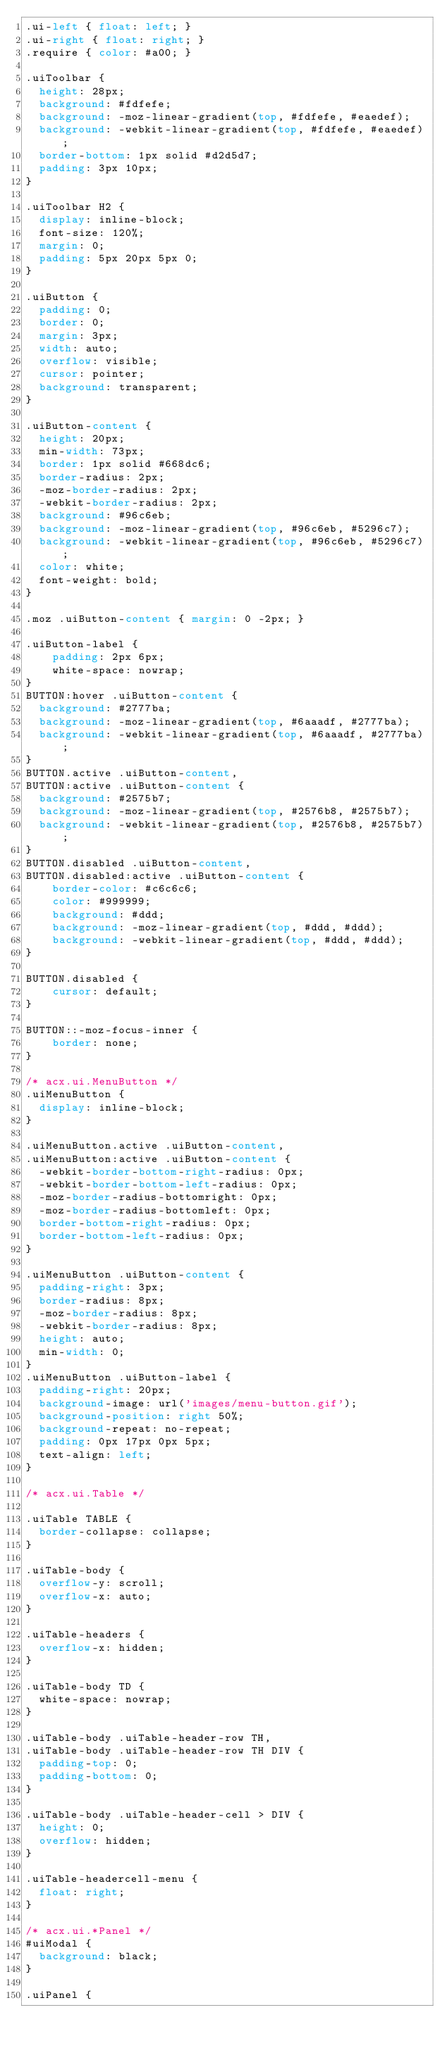Convert code to text. <code><loc_0><loc_0><loc_500><loc_500><_CSS_>.ui-left { float: left; }
.ui-right { float: right; }
.require { color: #a00; }

.uiToolbar {
	height: 28px;
	background: #fdfefe;
	background: -moz-linear-gradient(top, #fdfefe, #eaedef);
	background: -webkit-linear-gradient(top, #fdfefe, #eaedef);
	border-bottom: 1px solid #d2d5d7;
	padding: 3px 10px;
}

.uiToolbar H2 {
	display: inline-block;
	font-size: 120%;
	margin: 0;
	padding: 5px 20px 5px 0;
}

.uiButton {
	padding: 0;
	border: 0;
	margin: 3px;
	width: auto;
	overflow: visible;
	cursor: pointer;
	background: transparent;
}

.uiButton-content {
	height: 20px;
	min-width: 73px;
	border: 1px solid #668dc6;
	border-radius: 2px;
	-moz-border-radius: 2px;
	-webkit-border-radius: 2px;
	background: #96c6eb;
	background: -moz-linear-gradient(top, #96c6eb, #5296c7);
	background: -webkit-linear-gradient(top, #96c6eb, #5296c7);
	color: white;
	font-weight: bold;
}

.moz .uiButton-content { margin: 0 -2px; }

.uiButton-label {
    padding: 2px 6px;
    white-space: nowrap;
}
BUTTON:hover .uiButton-content {
	background: #2777ba;
	background: -moz-linear-gradient(top, #6aaadf, #2777ba);
	background: -webkit-linear-gradient(top, #6aaadf, #2777ba);
}
BUTTON.active .uiButton-content,
BUTTON:active .uiButton-content {
	background: #2575b7;
	background: -moz-linear-gradient(top, #2576b8, #2575b7);
	background: -webkit-linear-gradient(top, #2576b8, #2575b7);
}
BUTTON.disabled .uiButton-content,
BUTTON.disabled:active .uiButton-content {
    border-color: #c6c6c6;
    color: #999999;
    background: #ddd;
    background: -moz-linear-gradient(top, #ddd, #ddd);
    background: -webkit-linear-gradient(top, #ddd, #ddd);
}

BUTTON.disabled {
    cursor: default;
}

BUTTON::-moz-focus-inner {
    border: none;
}

/* acx.ui.MenuButton */
.uiMenuButton {
	display: inline-block;
}

.uiMenuButton.active .uiButton-content,
.uiMenuButton:active .uiButton-content {
	-webkit-border-bottom-right-radius: 0px;
	-webkit-border-bottom-left-radius: 0px;
	-moz-border-radius-bottomright: 0px;
	-moz-border-radius-bottomleft: 0px;
	border-bottom-right-radius: 0px;
	border-bottom-left-radius: 0px;
}

.uiMenuButton .uiButton-content {
	padding-right: 3px;
	border-radius: 8px;
	-moz-border-radius: 8px;
	-webkit-border-radius: 8px;
	height: auto;
	min-width: 0;
}
.uiMenuButton .uiButton-label {
	padding-right: 20px;
	background-image: url('images/menu-button.gif');
	background-position: right 50%;
	background-repeat: no-repeat;
	padding: 0px 17px 0px 5px;
	text-align: left;
}

/* acx.ui.Table */

.uiTable TABLE {
	border-collapse: collapse;
}

.uiTable-body {
	overflow-y: scroll;
	overflow-x: auto;
}

.uiTable-headers {
	overflow-x: hidden;
}

.uiTable-body TD {
	white-space: nowrap;
}

.uiTable-body .uiTable-header-row TH,
.uiTable-body .uiTable-header-row TH DIV {
	padding-top: 0;
	padding-bottom: 0;
}

.uiTable-body .uiTable-header-cell > DIV {
	height: 0;
	overflow: hidden;
}

.uiTable-headercell-menu {
	float: right;
}

/* acx.ui.*Panel */
#uiModal {
	background: black;
}

.uiPanel {</code> 